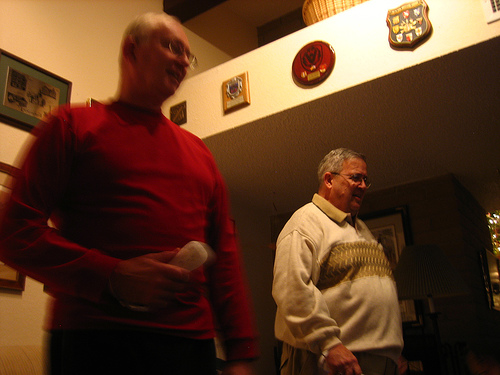What is the man in the foreground doing? The man in the foreground seems to be in the middle of a conversation or reacting to something, as he holds a remote control but is looking away from it, possibly engaging with someone or something outside the frame. 